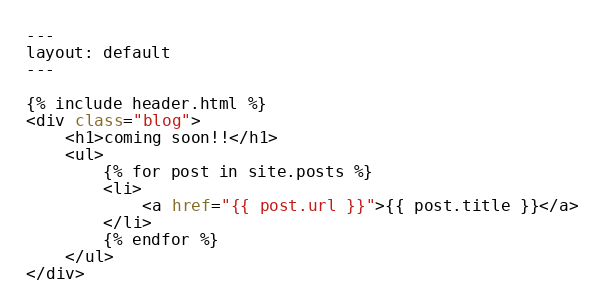Convert code to text. <code><loc_0><loc_0><loc_500><loc_500><_HTML_>---
layout: default
---

{% include header.html %}
<div class="blog">
    <h1>coming soon!!</h1>
    <ul>
        {% for post in site.posts %}
        <li>
            <a href="{{ post.url }}">{{ post.title }}</a>
        </li>
        {% endfor %}
    </ul>
</div>
</code> 